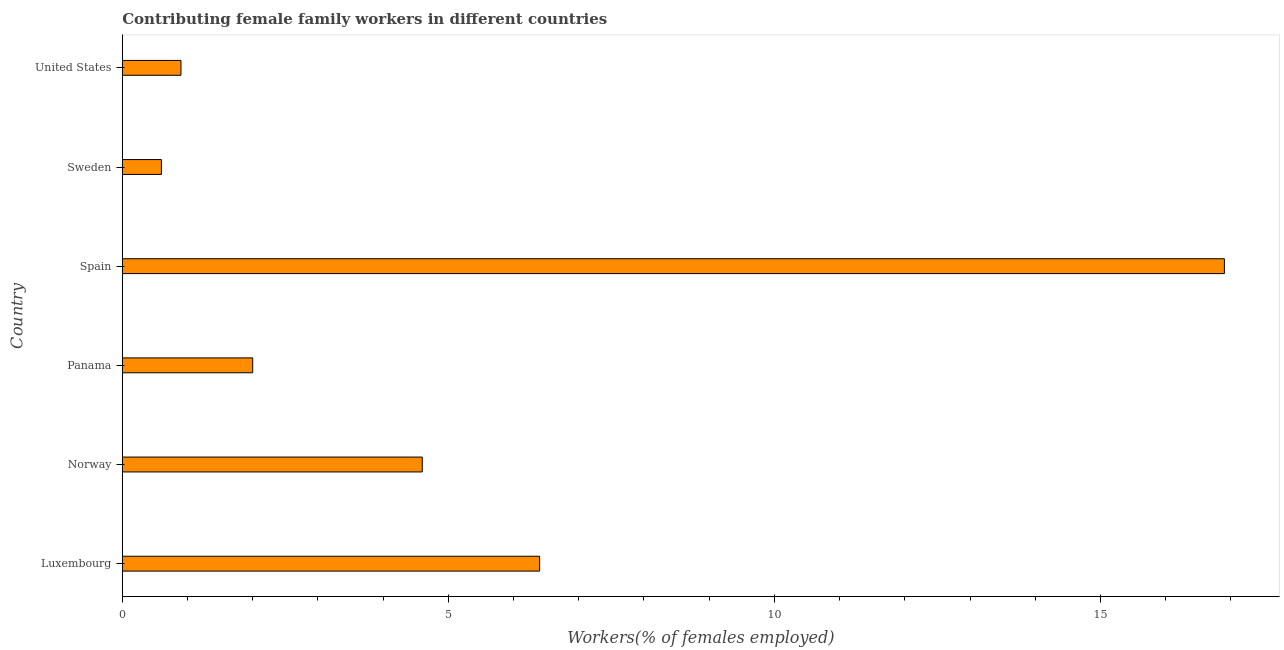Does the graph contain any zero values?
Provide a succinct answer. No. What is the title of the graph?
Keep it short and to the point. Contributing female family workers in different countries. What is the label or title of the X-axis?
Provide a short and direct response. Workers(% of females employed). What is the contributing female family workers in Sweden?
Provide a short and direct response. 0.6. Across all countries, what is the maximum contributing female family workers?
Your answer should be compact. 16.9. Across all countries, what is the minimum contributing female family workers?
Your answer should be very brief. 0.6. In which country was the contributing female family workers maximum?
Provide a succinct answer. Spain. In which country was the contributing female family workers minimum?
Offer a terse response. Sweden. What is the sum of the contributing female family workers?
Your answer should be very brief. 31.4. What is the average contributing female family workers per country?
Ensure brevity in your answer.  5.23. What is the median contributing female family workers?
Your answer should be compact. 3.3. What is the ratio of the contributing female family workers in Norway to that in Sweden?
Keep it short and to the point. 7.67. Is the sum of the contributing female family workers in Norway and Panama greater than the maximum contributing female family workers across all countries?
Make the answer very short. No. What is the difference between the highest and the lowest contributing female family workers?
Make the answer very short. 16.3. In how many countries, is the contributing female family workers greater than the average contributing female family workers taken over all countries?
Your answer should be compact. 2. What is the Workers(% of females employed) of Luxembourg?
Offer a very short reply. 6.4. What is the Workers(% of females employed) in Norway?
Provide a short and direct response. 4.6. What is the Workers(% of females employed) in Panama?
Ensure brevity in your answer.  2. What is the Workers(% of females employed) in Spain?
Make the answer very short. 16.9. What is the Workers(% of females employed) in Sweden?
Make the answer very short. 0.6. What is the Workers(% of females employed) of United States?
Give a very brief answer. 0.9. What is the difference between the Workers(% of females employed) in Luxembourg and Spain?
Offer a terse response. -10.5. What is the difference between the Workers(% of females employed) in Luxembourg and Sweden?
Ensure brevity in your answer.  5.8. What is the difference between the Workers(% of females employed) in Norway and Panama?
Your answer should be very brief. 2.6. What is the difference between the Workers(% of females employed) in Norway and Spain?
Ensure brevity in your answer.  -12.3. What is the difference between the Workers(% of females employed) in Norway and Sweden?
Offer a terse response. 4. What is the difference between the Workers(% of females employed) in Norway and United States?
Keep it short and to the point. 3.7. What is the difference between the Workers(% of females employed) in Panama and Spain?
Your answer should be very brief. -14.9. What is the difference between the Workers(% of females employed) in Panama and Sweden?
Make the answer very short. 1.4. What is the difference between the Workers(% of females employed) in Panama and United States?
Give a very brief answer. 1.1. What is the ratio of the Workers(% of females employed) in Luxembourg to that in Norway?
Keep it short and to the point. 1.39. What is the ratio of the Workers(% of females employed) in Luxembourg to that in Panama?
Ensure brevity in your answer.  3.2. What is the ratio of the Workers(% of females employed) in Luxembourg to that in Spain?
Keep it short and to the point. 0.38. What is the ratio of the Workers(% of females employed) in Luxembourg to that in Sweden?
Give a very brief answer. 10.67. What is the ratio of the Workers(% of females employed) in Luxembourg to that in United States?
Offer a terse response. 7.11. What is the ratio of the Workers(% of females employed) in Norway to that in Spain?
Your response must be concise. 0.27. What is the ratio of the Workers(% of females employed) in Norway to that in Sweden?
Your response must be concise. 7.67. What is the ratio of the Workers(% of females employed) in Norway to that in United States?
Offer a terse response. 5.11. What is the ratio of the Workers(% of females employed) in Panama to that in Spain?
Offer a very short reply. 0.12. What is the ratio of the Workers(% of females employed) in Panama to that in Sweden?
Provide a succinct answer. 3.33. What is the ratio of the Workers(% of females employed) in Panama to that in United States?
Provide a succinct answer. 2.22. What is the ratio of the Workers(% of females employed) in Spain to that in Sweden?
Make the answer very short. 28.17. What is the ratio of the Workers(% of females employed) in Spain to that in United States?
Your answer should be compact. 18.78. What is the ratio of the Workers(% of females employed) in Sweden to that in United States?
Your response must be concise. 0.67. 